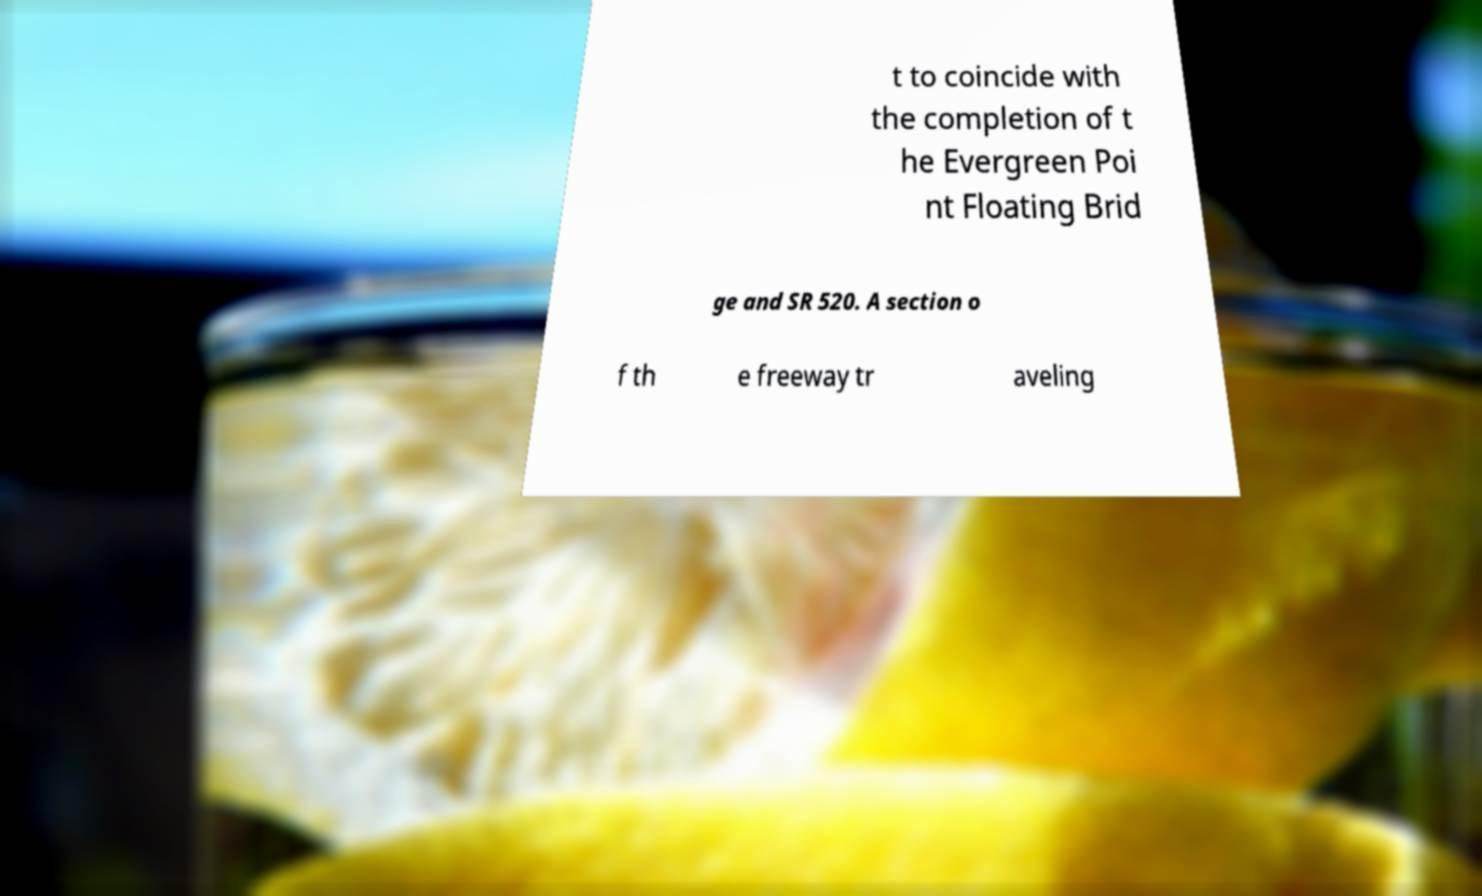Please read and relay the text visible in this image. What does it say? t to coincide with the completion of t he Evergreen Poi nt Floating Brid ge and SR 520. A section o f th e freeway tr aveling 